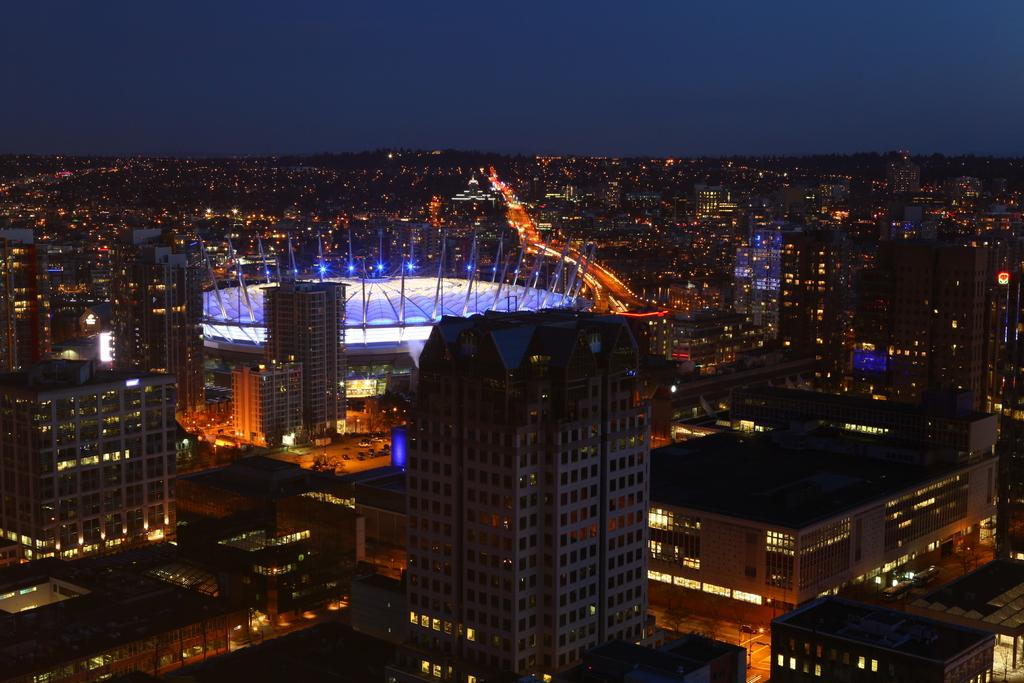What type of structures can be seen in the image? There are buildings with windows in the image. What can be seen illuminating the scene in the image? There are lights visible in the image. What type of transportation infrastructure is present in the image? There are roads in the image. What part of the natural environment is visible in the image? The sky is visible in the background of the image. How does the image demonstrate the process of addition? The image does not demonstrate the process of addition; it is a scene featuring buildings, lights, roads, and the sky. 